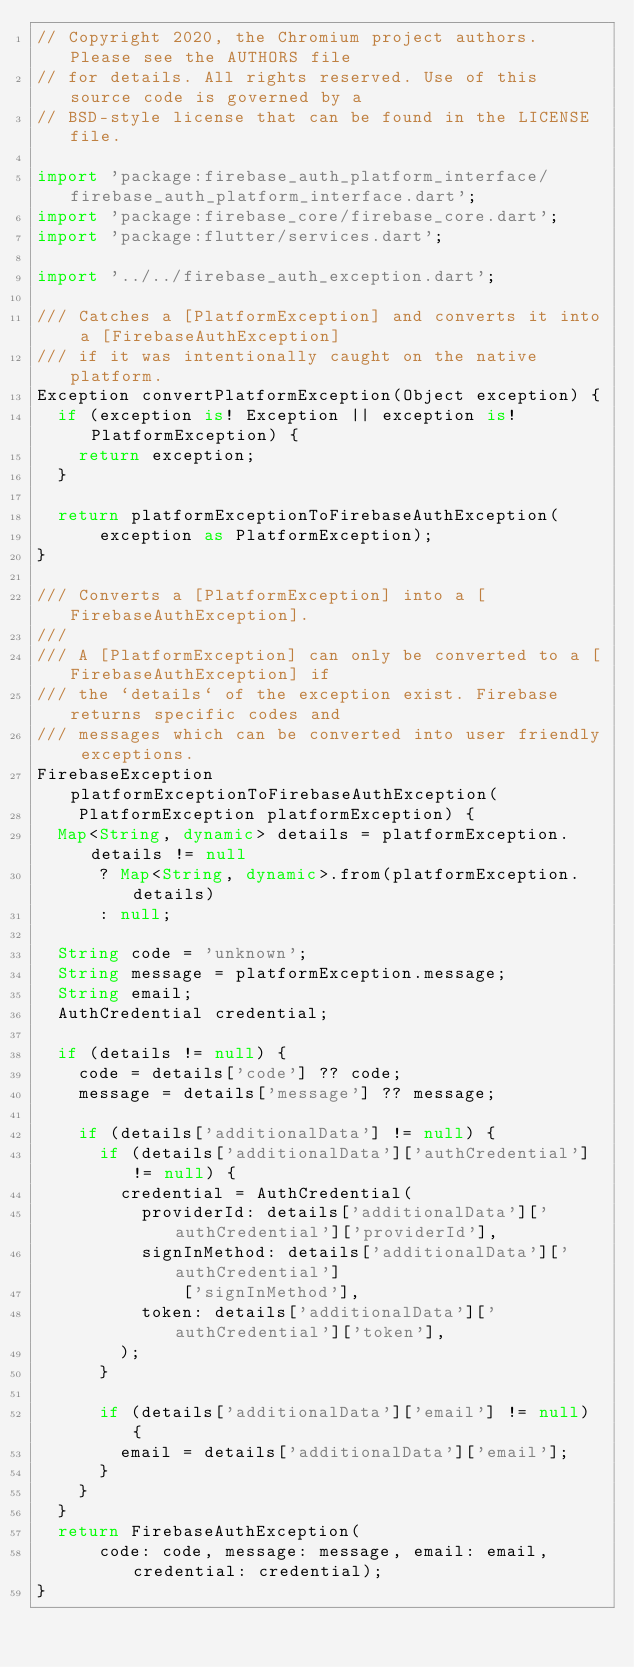Convert code to text. <code><loc_0><loc_0><loc_500><loc_500><_Dart_>// Copyright 2020, the Chromium project authors.  Please see the AUTHORS file
// for details. All rights reserved. Use of this source code is governed by a
// BSD-style license that can be found in the LICENSE file.

import 'package:firebase_auth_platform_interface/firebase_auth_platform_interface.dart';
import 'package:firebase_core/firebase_core.dart';
import 'package:flutter/services.dart';

import '../../firebase_auth_exception.dart';

/// Catches a [PlatformException] and converts it into a [FirebaseAuthException]
/// if it was intentionally caught on the native platform.
Exception convertPlatformException(Object exception) {
  if (exception is! Exception || exception is! PlatformException) {
    return exception;
  }

  return platformExceptionToFirebaseAuthException(
      exception as PlatformException);
}

/// Converts a [PlatformException] into a [FirebaseAuthException].
///
/// A [PlatformException] can only be converted to a [FirebaseAuthException] if
/// the `details` of the exception exist. Firebase returns specific codes and
/// messages which can be converted into user friendly exceptions.
FirebaseException platformExceptionToFirebaseAuthException(
    PlatformException platformException) {
  Map<String, dynamic> details = platformException.details != null
      ? Map<String, dynamic>.from(platformException.details)
      : null;

  String code = 'unknown';
  String message = platformException.message;
  String email;
  AuthCredential credential;

  if (details != null) {
    code = details['code'] ?? code;
    message = details['message'] ?? message;

    if (details['additionalData'] != null) {
      if (details['additionalData']['authCredential'] != null) {
        credential = AuthCredential(
          providerId: details['additionalData']['authCredential']['providerId'],
          signInMethod: details['additionalData']['authCredential']
              ['signInMethod'],
          token: details['additionalData']['authCredential']['token'],
        );
      }

      if (details['additionalData']['email'] != null) {
        email = details['additionalData']['email'];
      }
    }
  }
  return FirebaseAuthException(
      code: code, message: message, email: email, credential: credential);
}
</code> 